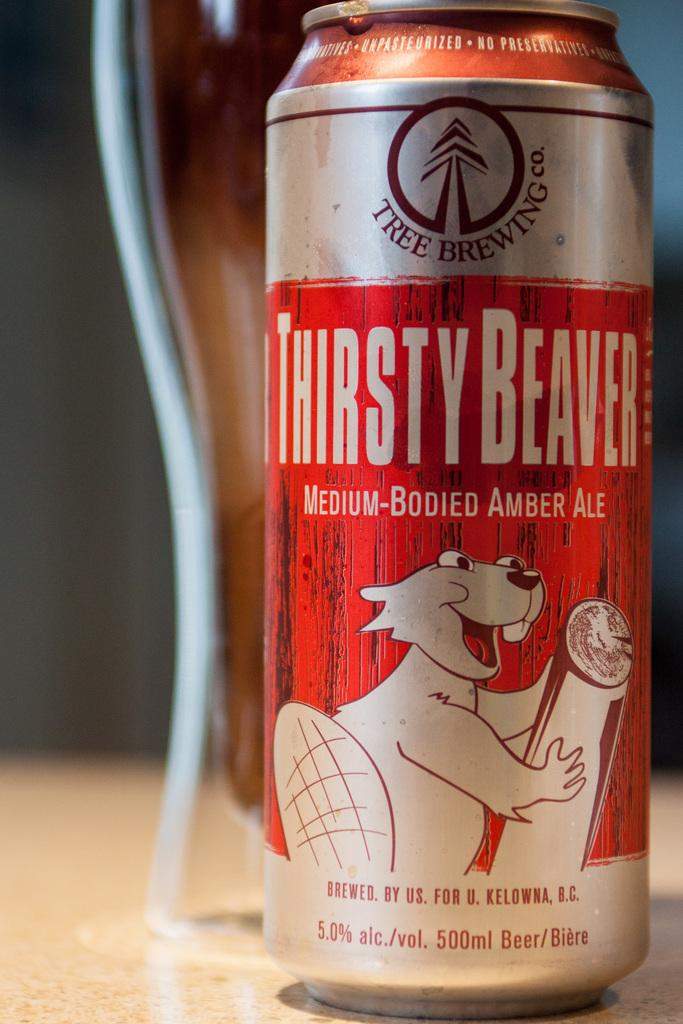<image>
Create a compact narrative representing the image presented. A can of Thirsty Beaver medium-bodied amber ale sits on a counter. 